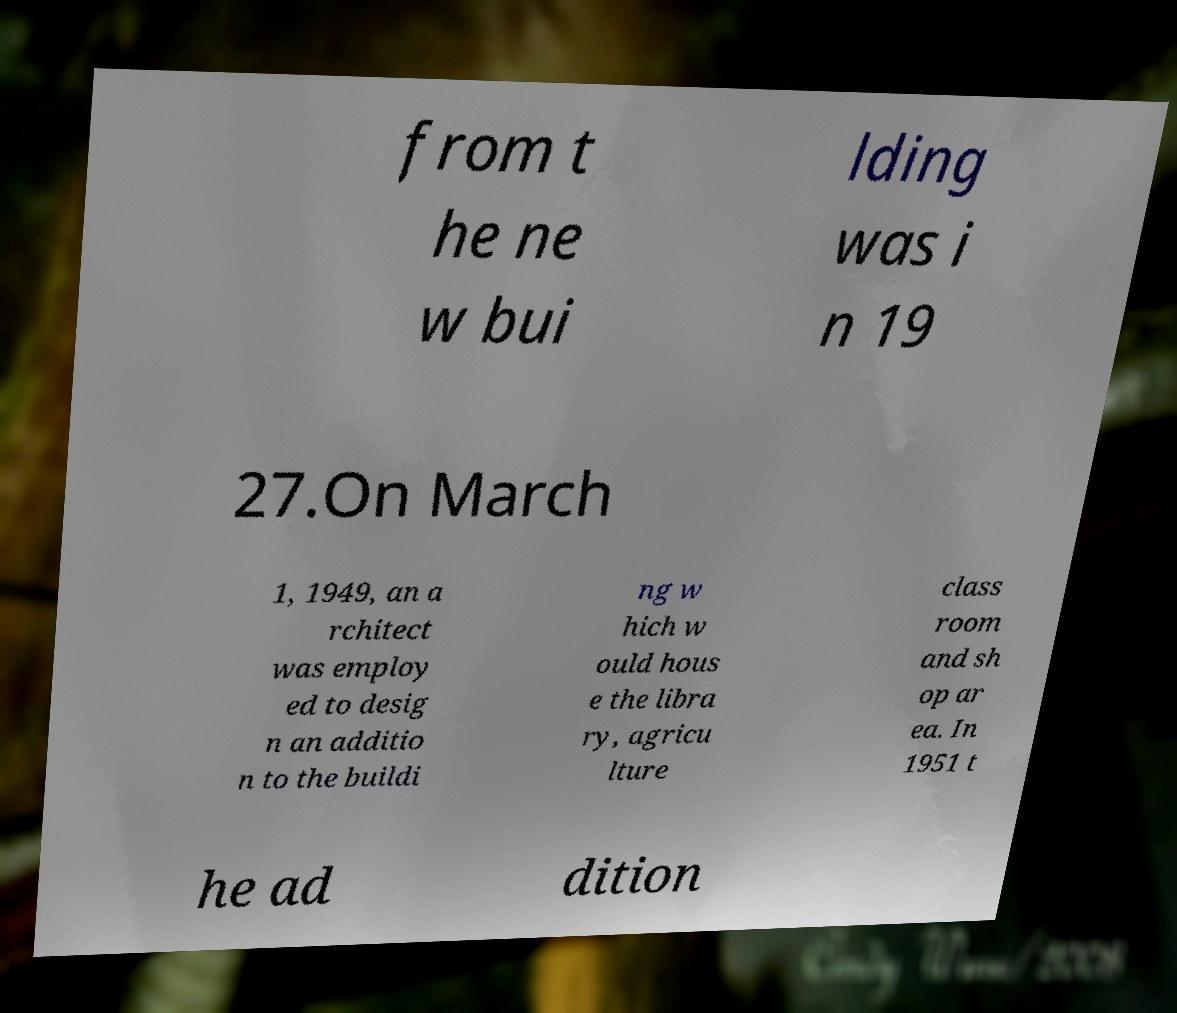Please identify and transcribe the text found in this image. from t he ne w bui lding was i n 19 27.On March 1, 1949, an a rchitect was employ ed to desig n an additio n to the buildi ng w hich w ould hous e the libra ry, agricu lture class room and sh op ar ea. In 1951 t he ad dition 